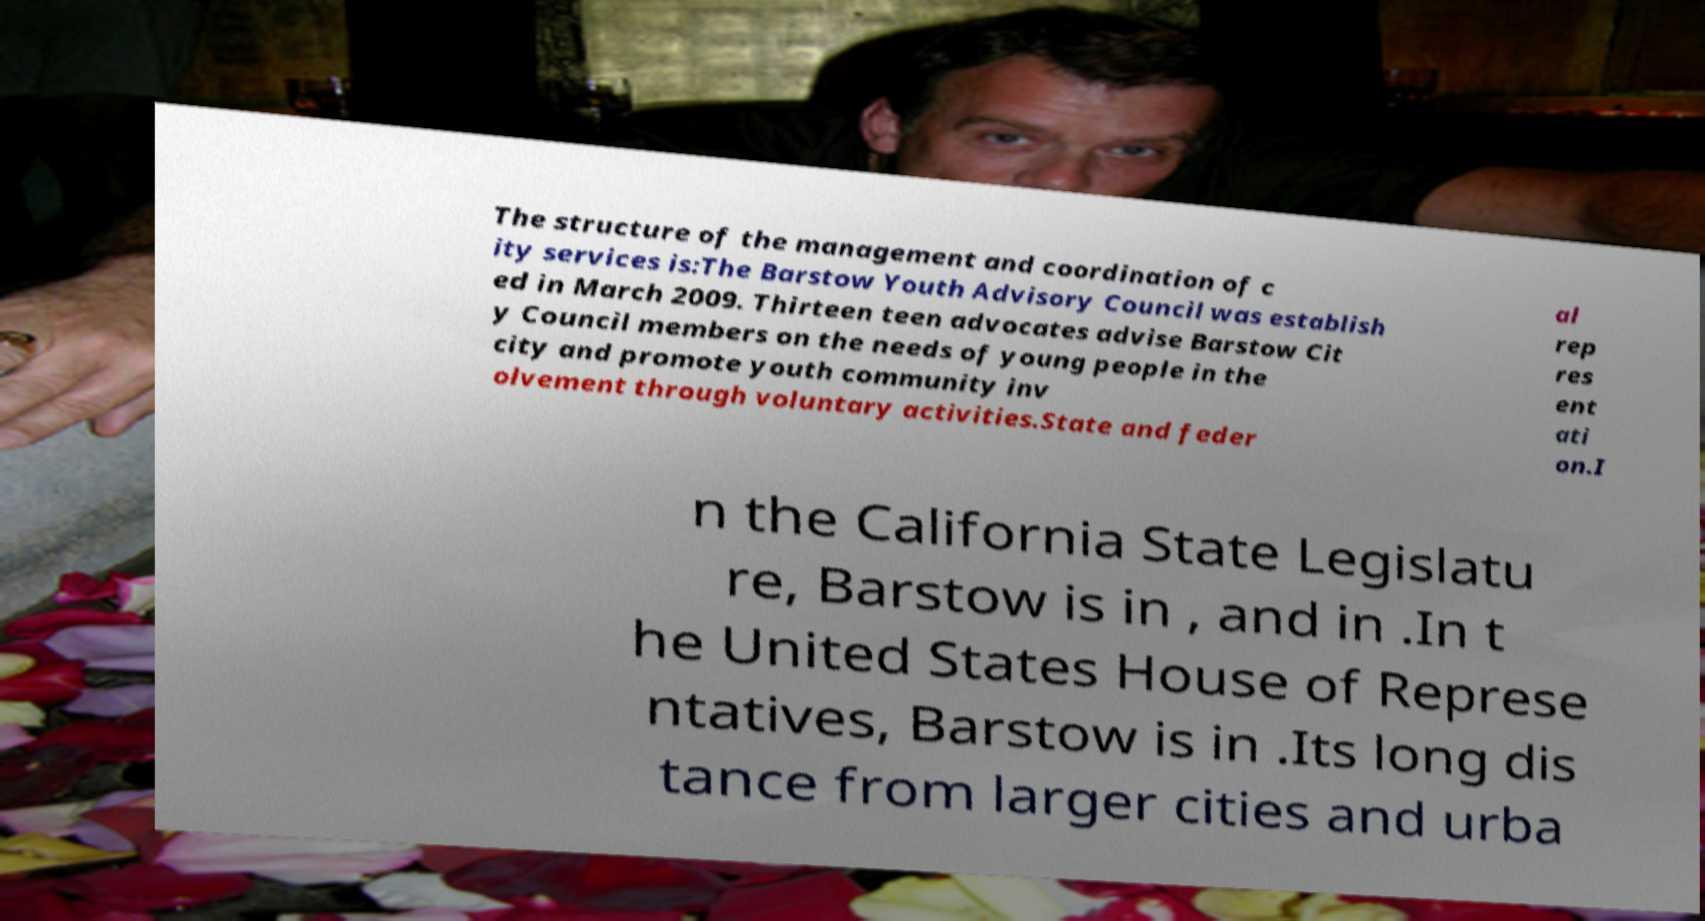Please read and relay the text visible in this image. What does it say? The structure of the management and coordination of c ity services is:The Barstow Youth Advisory Council was establish ed in March 2009. Thirteen teen advocates advise Barstow Cit y Council members on the needs of young people in the city and promote youth community inv olvement through voluntary activities.State and feder al rep res ent ati on.I n the California State Legislatu re, Barstow is in , and in .In t he United States House of Represe ntatives, Barstow is in .Its long dis tance from larger cities and urba 